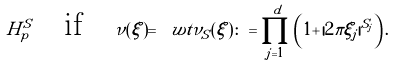Convert formula to latex. <formula><loc_0><loc_0><loc_500><loc_500>\, { H } _ { p } ^ { S } \quad \text {if} \quad \nu ( \xi ) = \ w t { \nu } _ { S } ( \xi ) \colon = \prod _ { j = 1 } ^ { d } \left ( 1 + \, | 2 \pi \xi _ { j } | ^ { S _ { j } } \right ) .</formula> 